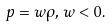Convert formula to latex. <formula><loc_0><loc_0><loc_500><loc_500>p = w \rho , \, w < 0 .</formula> 